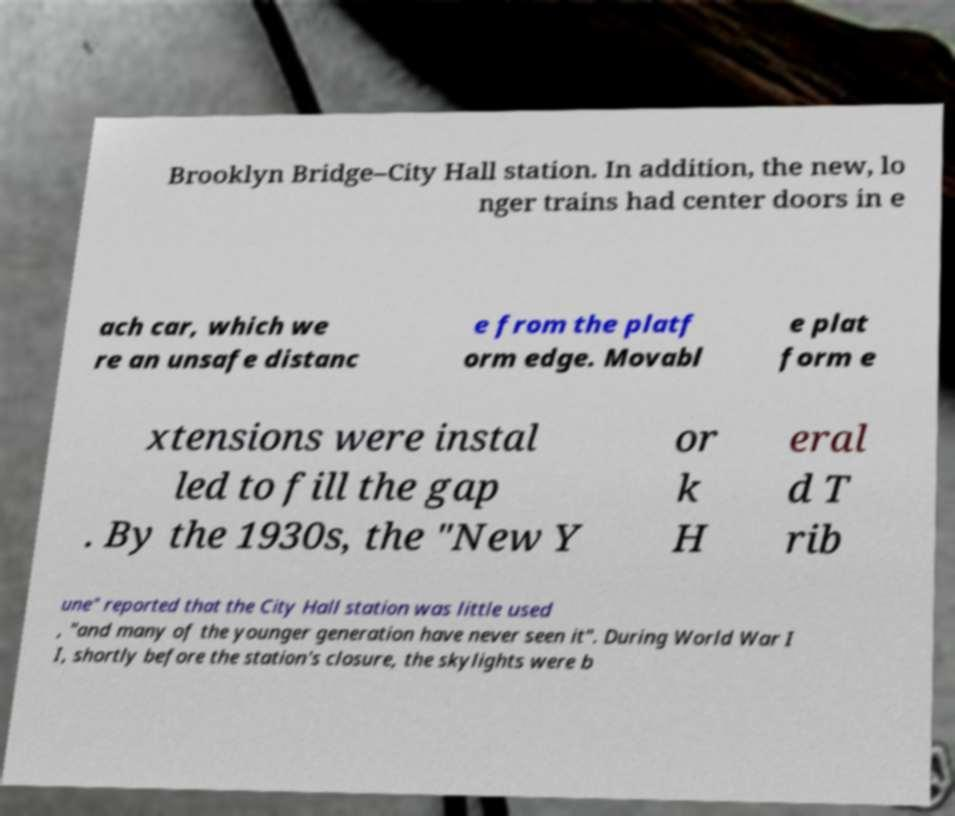What messages or text are displayed in this image? I need them in a readable, typed format. Brooklyn Bridge–City Hall station. In addition, the new, lo nger trains had center doors in e ach car, which we re an unsafe distanc e from the platf orm edge. Movabl e plat form e xtensions were instal led to fill the gap . By the 1930s, the "New Y or k H eral d T rib une" reported that the City Hall station was little used , "and many of the younger generation have never seen it". During World War I I, shortly before the station's closure, the skylights were b 